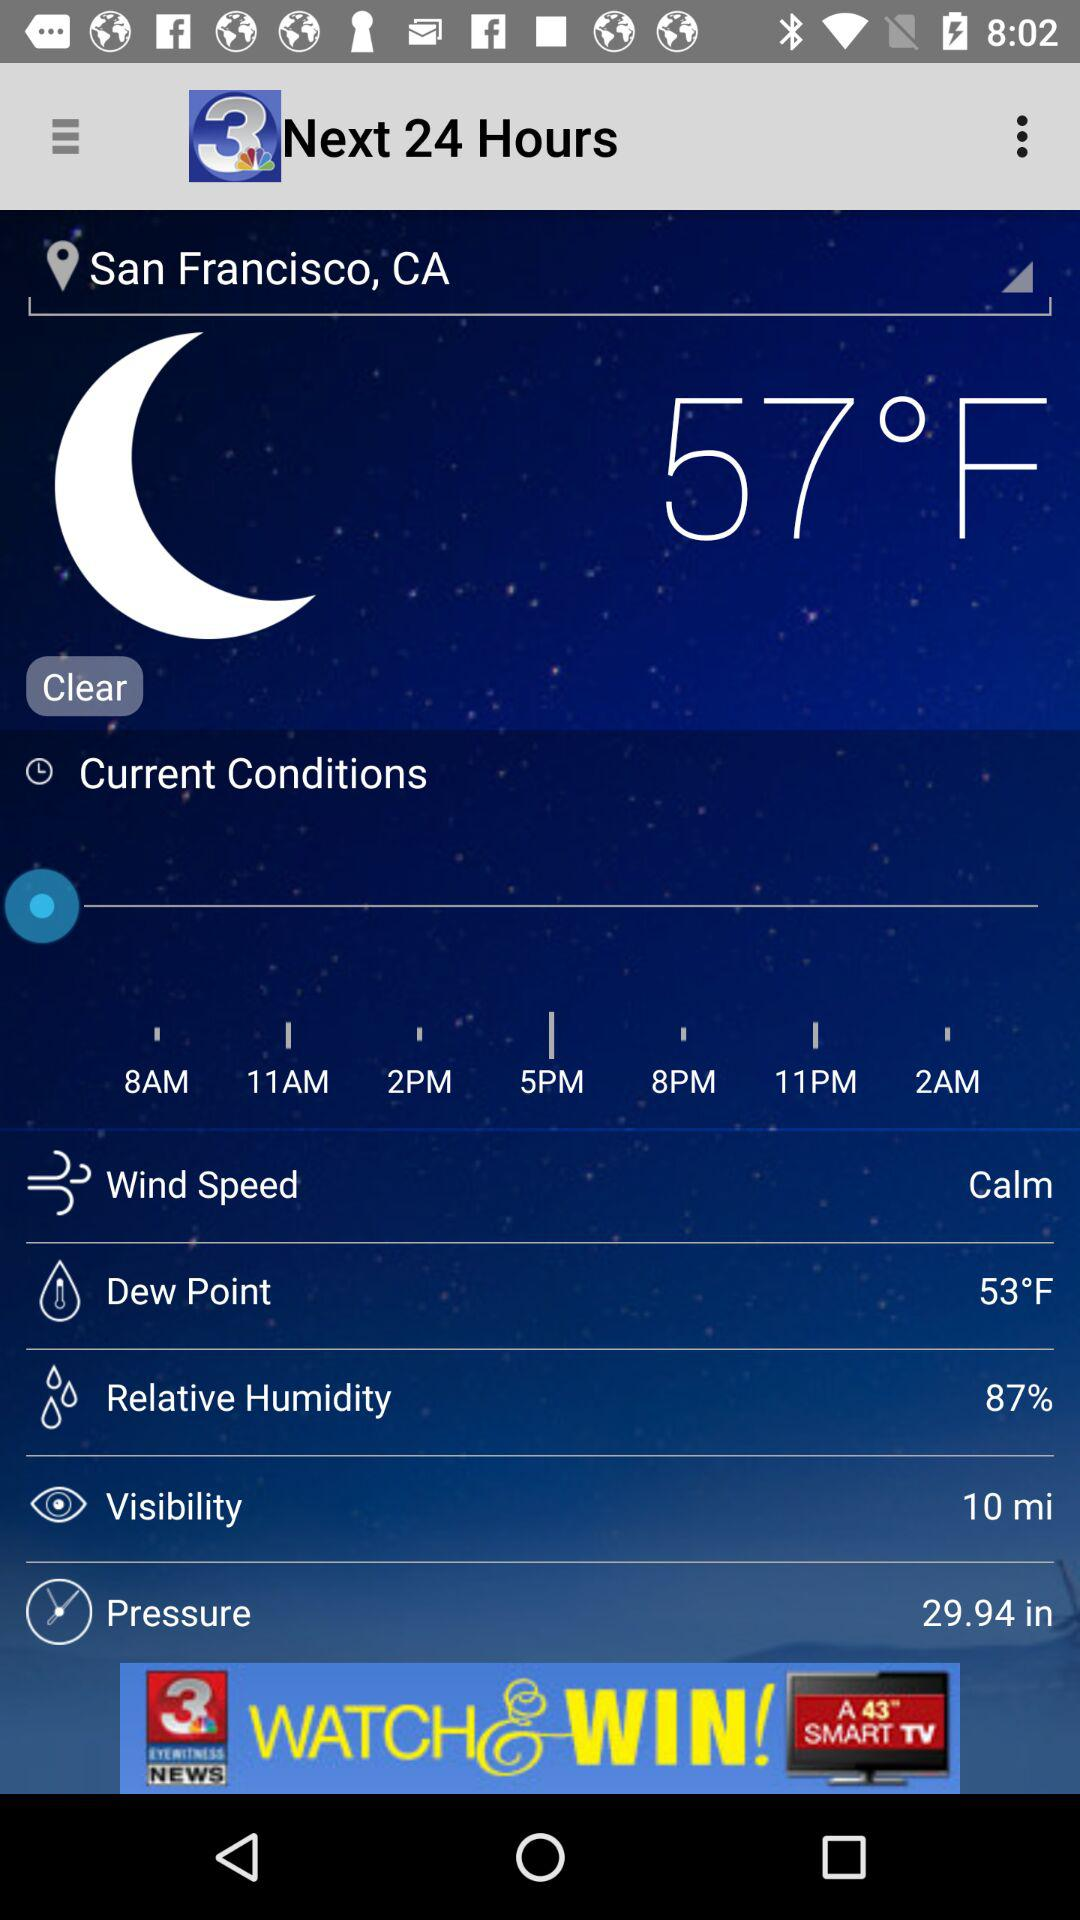What is the pressure? The pressure is 29.94 in. 